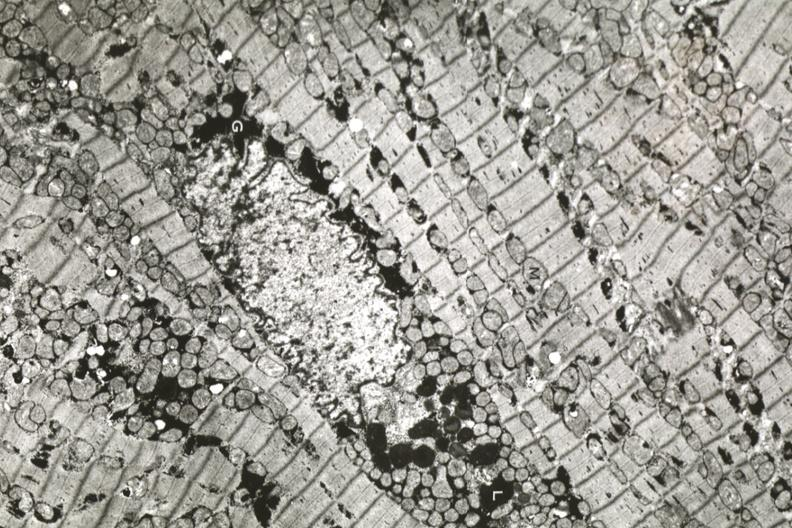what is present?
Answer the question using a single word or phrase. Cardiovascular 